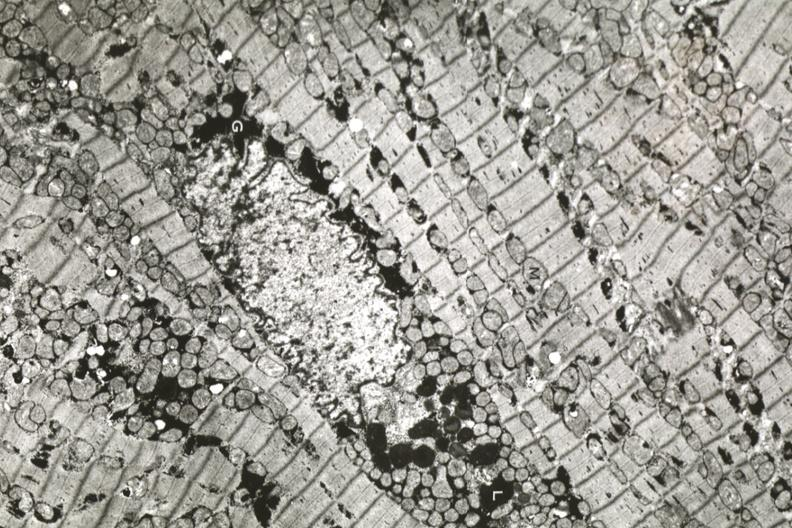what is present?
Answer the question using a single word or phrase. Cardiovascular 